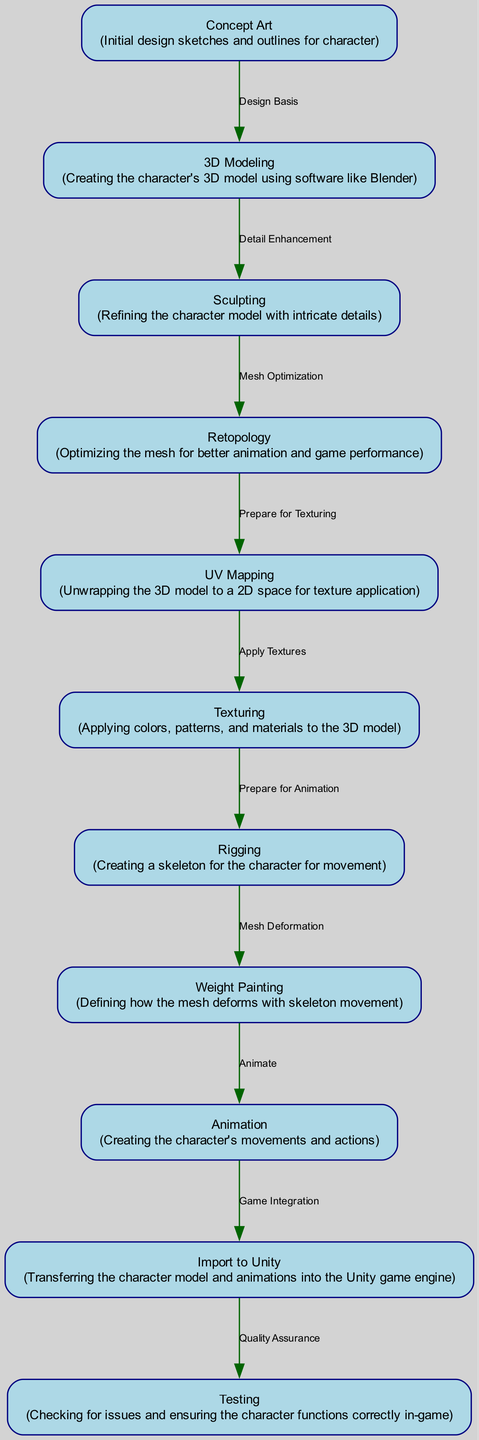What is the first step in the character creation workflow? The first step is conceptualizing the character through initial sketches, represented by the "Concept Art" node.
Answer: Concept Art How many nodes are there in this diagram? By counting all distinct elements connected by edges, the total number of nodes is 10.
Answer: 10 Which node directly follows the "Texturing" node? The node that comes after "Texturing" is "Rigging". In the diagram, this shows the flow from texturing to rigging.
Answer: Rigging What is the edge label between "Rigging" and "Weight Painting"? The edge label describes the relationship between these nodes, and it is "Mesh Deformation".
Answer: Mesh Deformation What is the last step in the character creation process? The diagram culminates in the "Testing" node, which is the final workflow step.
Answer: Testing What is the purpose of the "Retopology" node? "Retopology" serves to optimize the mesh for improved animation and performance. This is reflected in the node's description.
Answer: Optimizing the mesh Which two nodes are connected by the edge labeled "Game Integration"? The nodes linked by this edge are "Animation" and "Import to Unity", indicating the flow of integrating animations into the game engine.
Answer: Animation and Import to Unity What does the "Weight Painting" node define? This node specifies how the character's mesh will deform when the skeleton moves, as indicated in its description.
Answer: Mesh deformation 